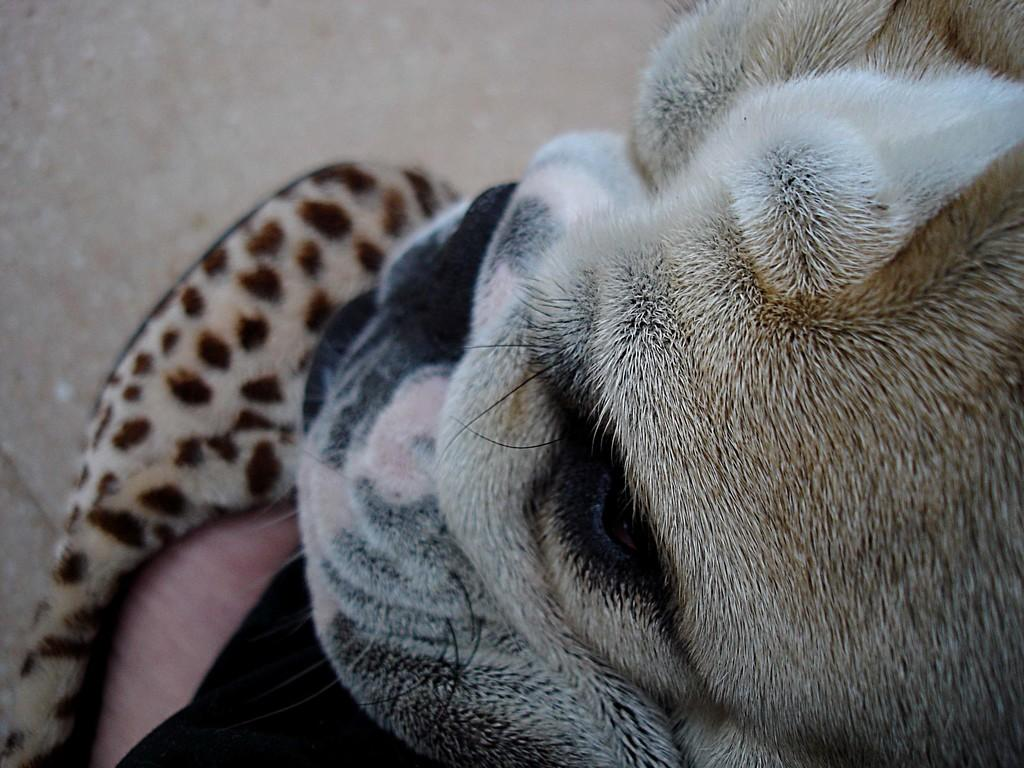What type of creature is in the image? There is an animal in the image, which looks like a dog. What is the dog doing in the image? The dog is sitting. What is visible at the bottom of the image? There is ground visible at the bottom of the image. How many hearts can be seen in the image? There are no hearts visible in the image. Are there any spiders present in the image? There is no mention of spiders in the provided facts, so we cannot determine if they are present in the image. 